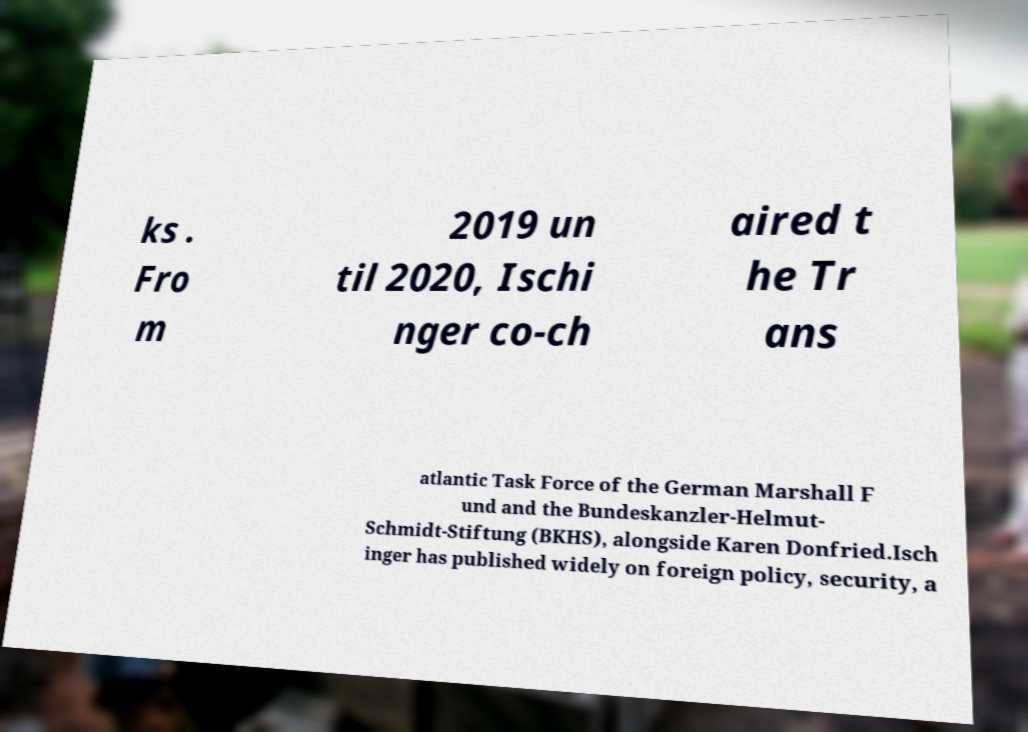I need the written content from this picture converted into text. Can you do that? ks . Fro m 2019 un til 2020, Ischi nger co-ch aired t he Tr ans atlantic Task Force of the German Marshall F und and the Bundeskanzler-Helmut- Schmidt-Stiftung (BKHS), alongside Karen Donfried.Isch inger has published widely on foreign policy, security, a 